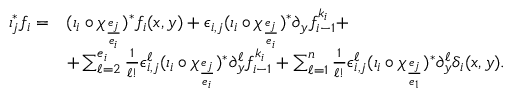Convert formula to latex. <formula><loc_0><loc_0><loc_500><loc_500>\begin{array} { r l } { \iota _ { j } ^ { \ast } f _ { i } = } & { ( \iota _ { i } \circ \chi _ { \frac { e _ { j } } { e _ { i } } } ) ^ { \ast } f _ { i } ( x , y ) + \epsilon _ { i , j } ( \iota _ { i } \circ \chi _ { \frac { e _ { j } } { e _ { i } } } ) ^ { \ast } \partial _ { y } f _ { i - 1 } ^ { k _ { i } } + } \\ & { + \sum _ { \ell = 2 } ^ { e _ { i } } \frac { 1 } { \ell ! } \epsilon _ { i , j } ^ { \ell } ( \iota _ { i } \circ \chi _ { \frac { e _ { j } } { e _ { i } } } ) ^ { \ast } \partial _ { y } ^ { \ell } f _ { i - 1 } ^ { k _ { i } } + \sum _ { \ell = 1 } ^ { n } \frac { 1 } { \ell ! } \epsilon _ { i , j } ^ { \ell } ( \iota _ { i } \circ \chi _ { \frac { e _ { j } } { e _ { 1 } } } ) ^ { \ast } \partial _ { y } ^ { \ell } \delta _ { i } ( x , y ) . } \end{array}</formula> 